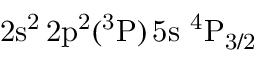<formula> <loc_0><loc_0><loc_500><loc_500>2 s ^ { 2 } \, 2 p ^ { 2 } ( ^ { 3 } P ) \, 5 s ^ { 4 } P _ { 3 / 2 }</formula> 